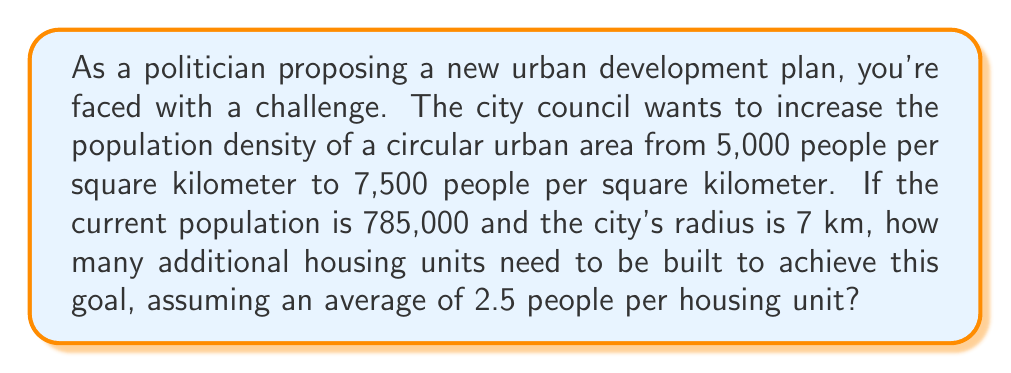Can you answer this question? Let's approach this step-by-step:

1) First, calculate the area of the city:
   Area = $\pi r^2$ = $\pi \cdot 7^2$ = $49\pi$ km²

2) Calculate the current population density:
   Current density = $\frac{\text{Current population}}{\text{Area}}$ = $\frac{785,000}{49\pi}$ ≈ 5,000 people/km²
   (This confirms the given information)

3) Calculate the target population for the new density:
   Target population = New density × Area
   = $7,500 \cdot 49\pi$ = $367,500\pi$ ≈ 1,155,215 people

4) Calculate the population increase:
   Population increase = Target population - Current population
   = $1,155,215 - 785,000$ = 370,215 people

5) Calculate the number of new housing units needed:
   New housing units = $\frac{\text{Population increase}}{\text{People per housing unit}}$
   = $\frac{370,215}{2.5}$ = 148,086

Therefore, 148,086 new housing units need to be built.
Answer: 148,086 housing units 